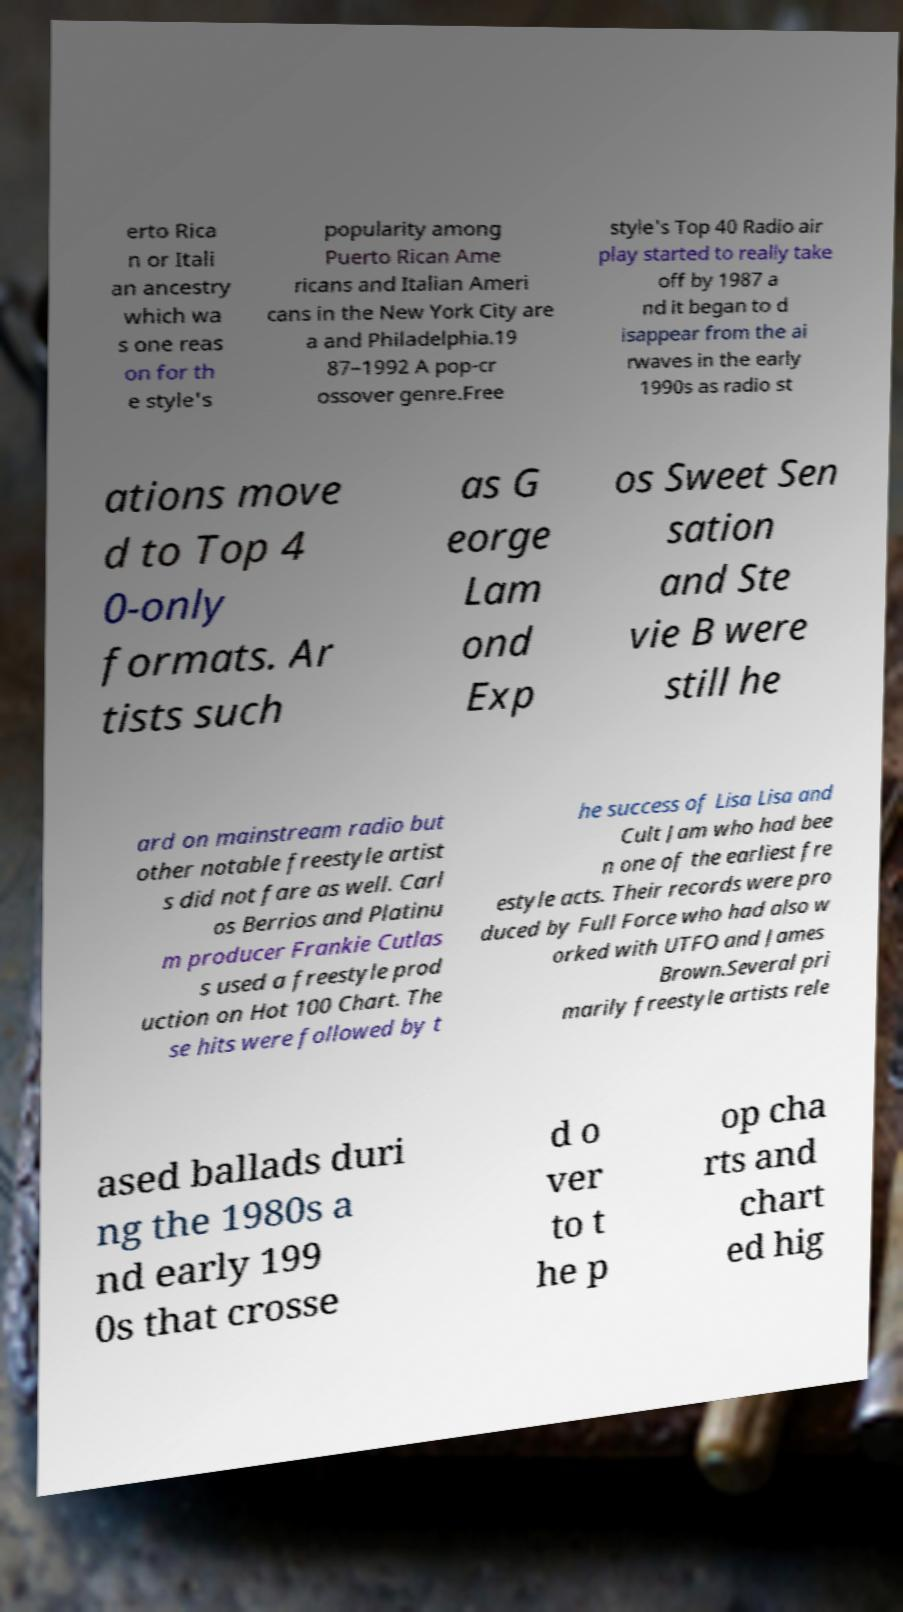Can you read and provide the text displayed in the image?This photo seems to have some interesting text. Can you extract and type it out for me? erto Rica n or Itali an ancestry which wa s one reas on for th e style's popularity among Puerto Rican Ame ricans and Italian Ameri cans in the New York City are a and Philadelphia.19 87–1992 A pop-cr ossover genre.Free style's Top 40 Radio air play started to really take off by 1987 a nd it began to d isappear from the ai rwaves in the early 1990s as radio st ations move d to Top 4 0-only formats. Ar tists such as G eorge Lam ond Exp os Sweet Sen sation and Ste vie B were still he ard on mainstream radio but other notable freestyle artist s did not fare as well. Carl os Berrios and Platinu m producer Frankie Cutlas s used a freestyle prod uction on Hot 100 Chart. The se hits were followed by t he success of Lisa Lisa and Cult Jam who had bee n one of the earliest fre estyle acts. Their records were pro duced by Full Force who had also w orked with UTFO and James Brown.Several pri marily freestyle artists rele ased ballads duri ng the 1980s a nd early 199 0s that crosse d o ver to t he p op cha rts and chart ed hig 